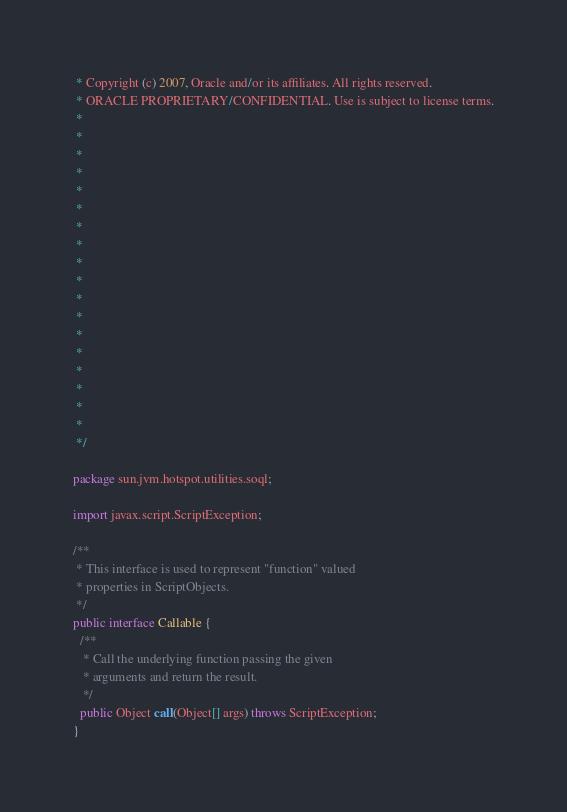<code> <loc_0><loc_0><loc_500><loc_500><_Java_> * Copyright (c) 2007, Oracle and/or its affiliates. All rights reserved.
 * ORACLE PROPRIETARY/CONFIDENTIAL. Use is subject to license terms.
 *
 *
 *
 *
 *
 *
 *
 *
 *
 *
 *
 *
 *
 *
 *
 *
 *
 *
 */

package sun.jvm.hotspot.utilities.soql;

import javax.script.ScriptException;

/**
 * This interface is used to represent "function" valued
 * properties in ScriptObjects.
 */
public interface Callable {
  /**
   * Call the underlying function passing the given
   * arguments and return the result.
   */
  public Object call(Object[] args) throws ScriptException;
}
</code> 